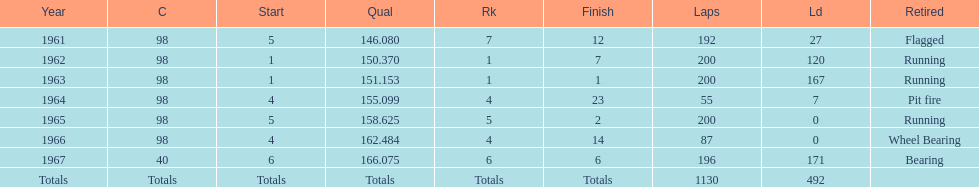Previous to 1965, when did jones have a number 5 start at the indy 500? 1961. 